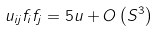<formula> <loc_0><loc_0><loc_500><loc_500>u _ { i j } f _ { i } f _ { j } = 5 u + O \left ( S ^ { 3 } \right )</formula> 